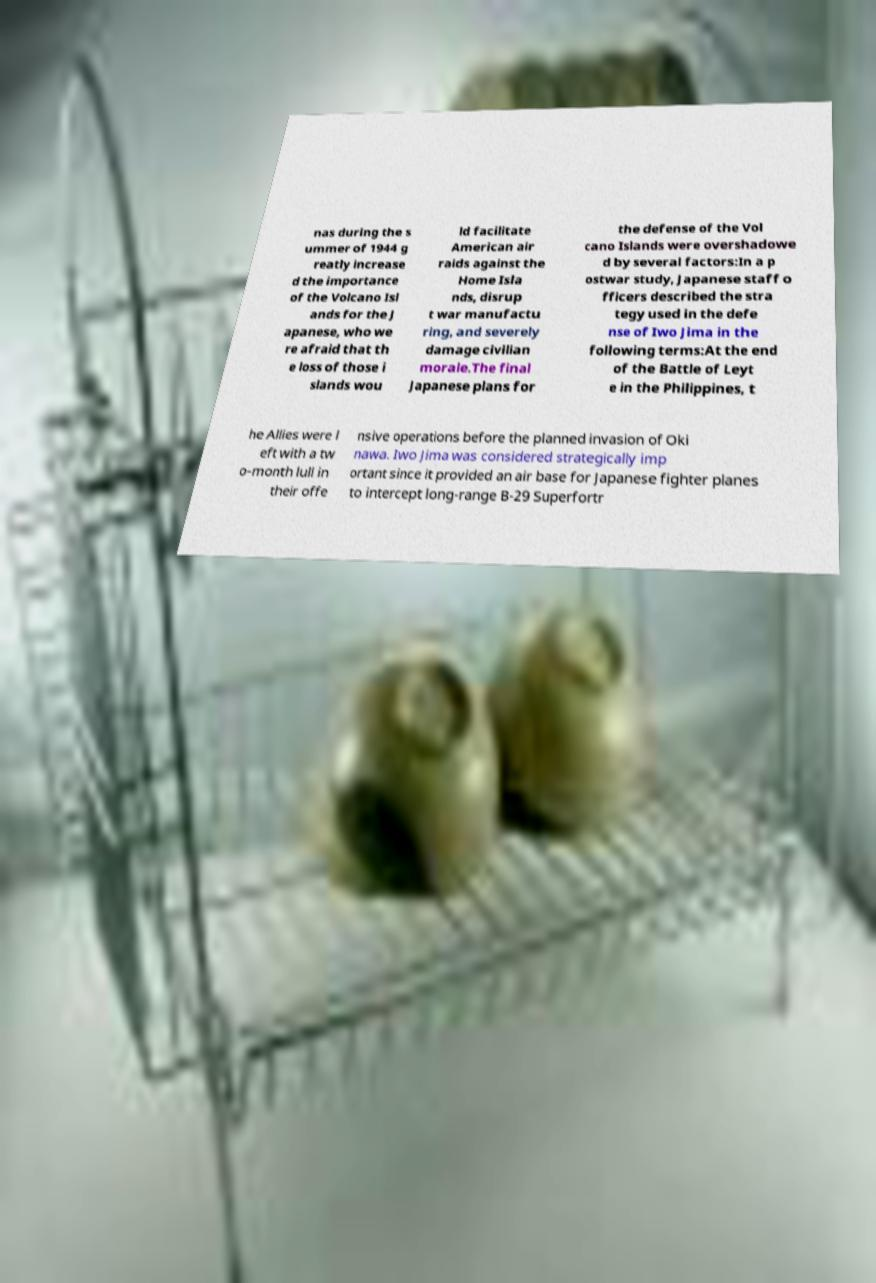Please identify and transcribe the text found in this image. nas during the s ummer of 1944 g reatly increase d the importance of the Volcano Isl ands for the J apanese, who we re afraid that th e loss of those i slands wou ld facilitate American air raids against the Home Isla nds, disrup t war manufactu ring, and severely damage civilian morale.The final Japanese plans for the defense of the Vol cano Islands were overshadowe d by several factors:In a p ostwar study, Japanese staff o fficers described the stra tegy used in the defe nse of Iwo Jima in the following terms:At the end of the Battle of Leyt e in the Philippines, t he Allies were l eft with a tw o-month lull in their offe nsive operations before the planned invasion of Oki nawa. Iwo Jima was considered strategically imp ortant since it provided an air base for Japanese fighter planes to intercept long-range B-29 Superfortr 